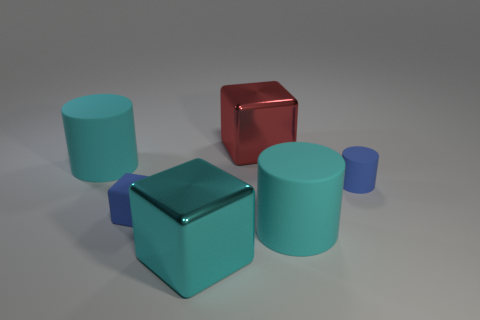Add 4 shiny cubes. How many objects exist? 10 Subtract all cyan blocks. How many blocks are left? 2 Subtract all small yellow metal cylinders. Subtract all small blue matte cylinders. How many objects are left? 5 Add 4 matte things. How many matte things are left? 8 Add 5 blue objects. How many blue objects exist? 7 Subtract all blue cubes. How many cubes are left? 2 Subtract 0 yellow cylinders. How many objects are left? 6 Subtract 2 blocks. How many blocks are left? 1 Subtract all blue cylinders. Subtract all green balls. How many cylinders are left? 2 Subtract all brown cubes. How many blue cylinders are left? 1 